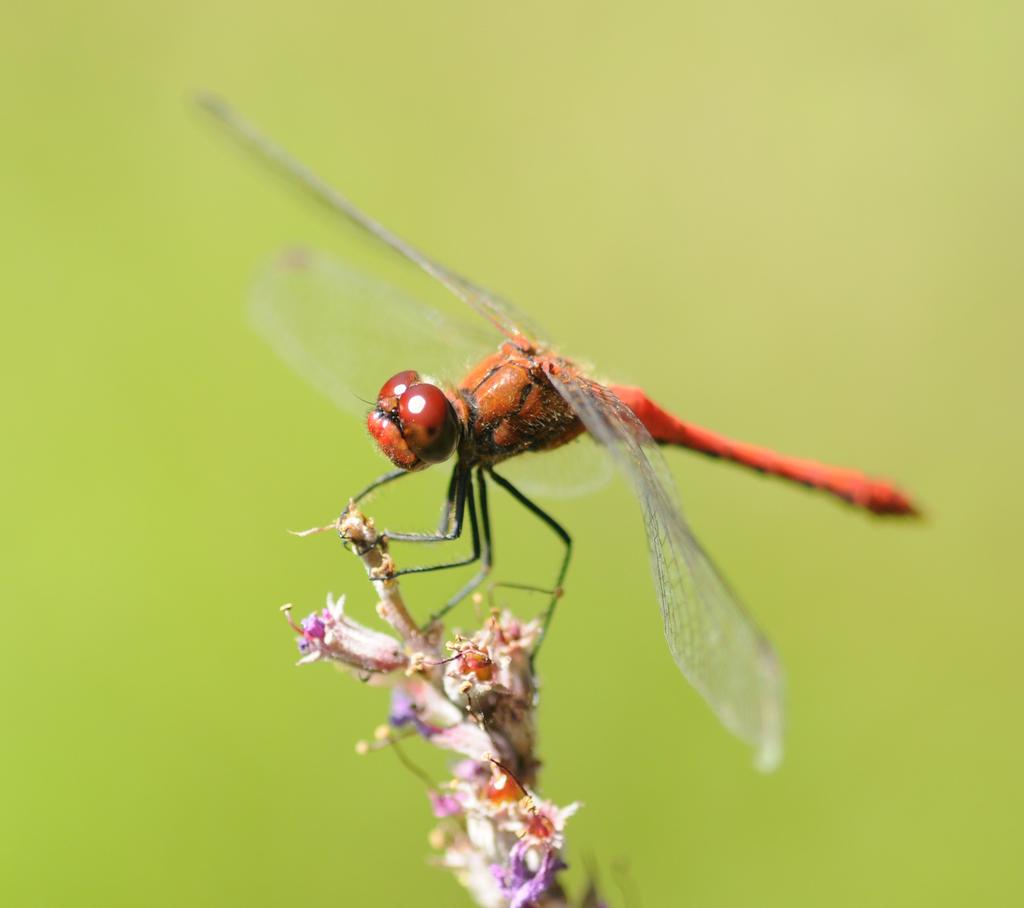What is present in the image? There is a fly in the image. Where is the fly located? The fly is standing on a plant. What type of hospital is depicted in the image? There is no hospital present in the image; it only features a fly standing on a plant. 